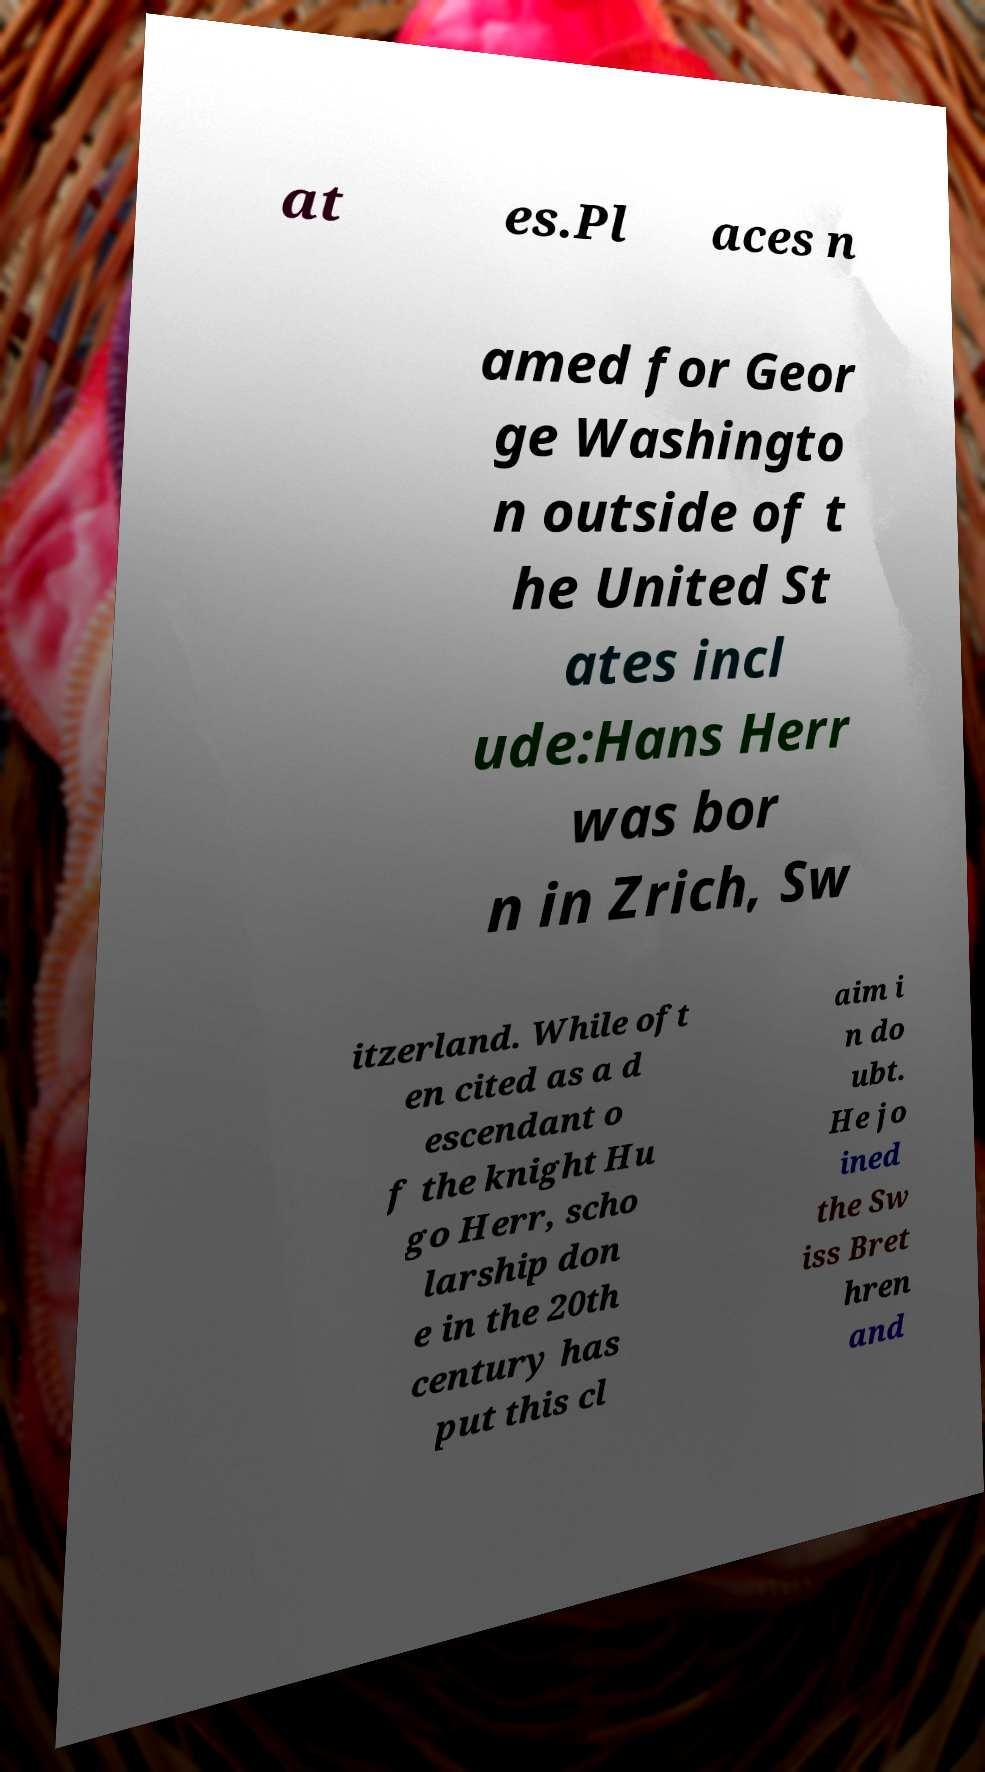Could you extract and type out the text from this image? at es.Pl aces n amed for Geor ge Washingto n outside of t he United St ates incl ude:Hans Herr was bor n in Zrich, Sw itzerland. While oft en cited as a d escendant o f the knight Hu go Herr, scho larship don e in the 20th century has put this cl aim i n do ubt. He jo ined the Sw iss Bret hren and 